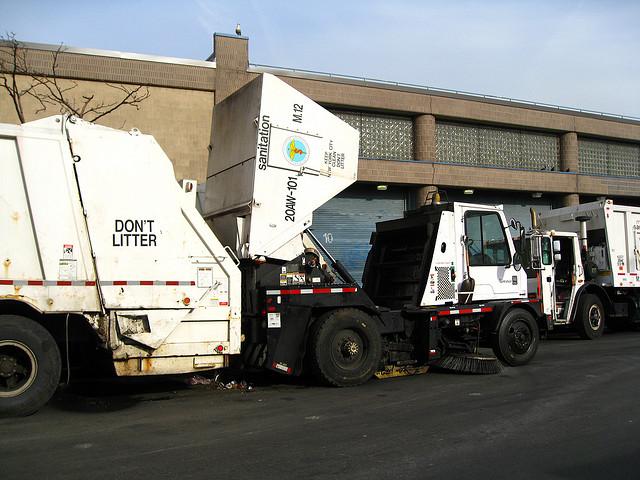What kind of truck is this?
Short answer required. Garbage. What does the truck say not to do?
Concise answer only. Litter. How many wheels are seen?
Keep it brief. 4. 